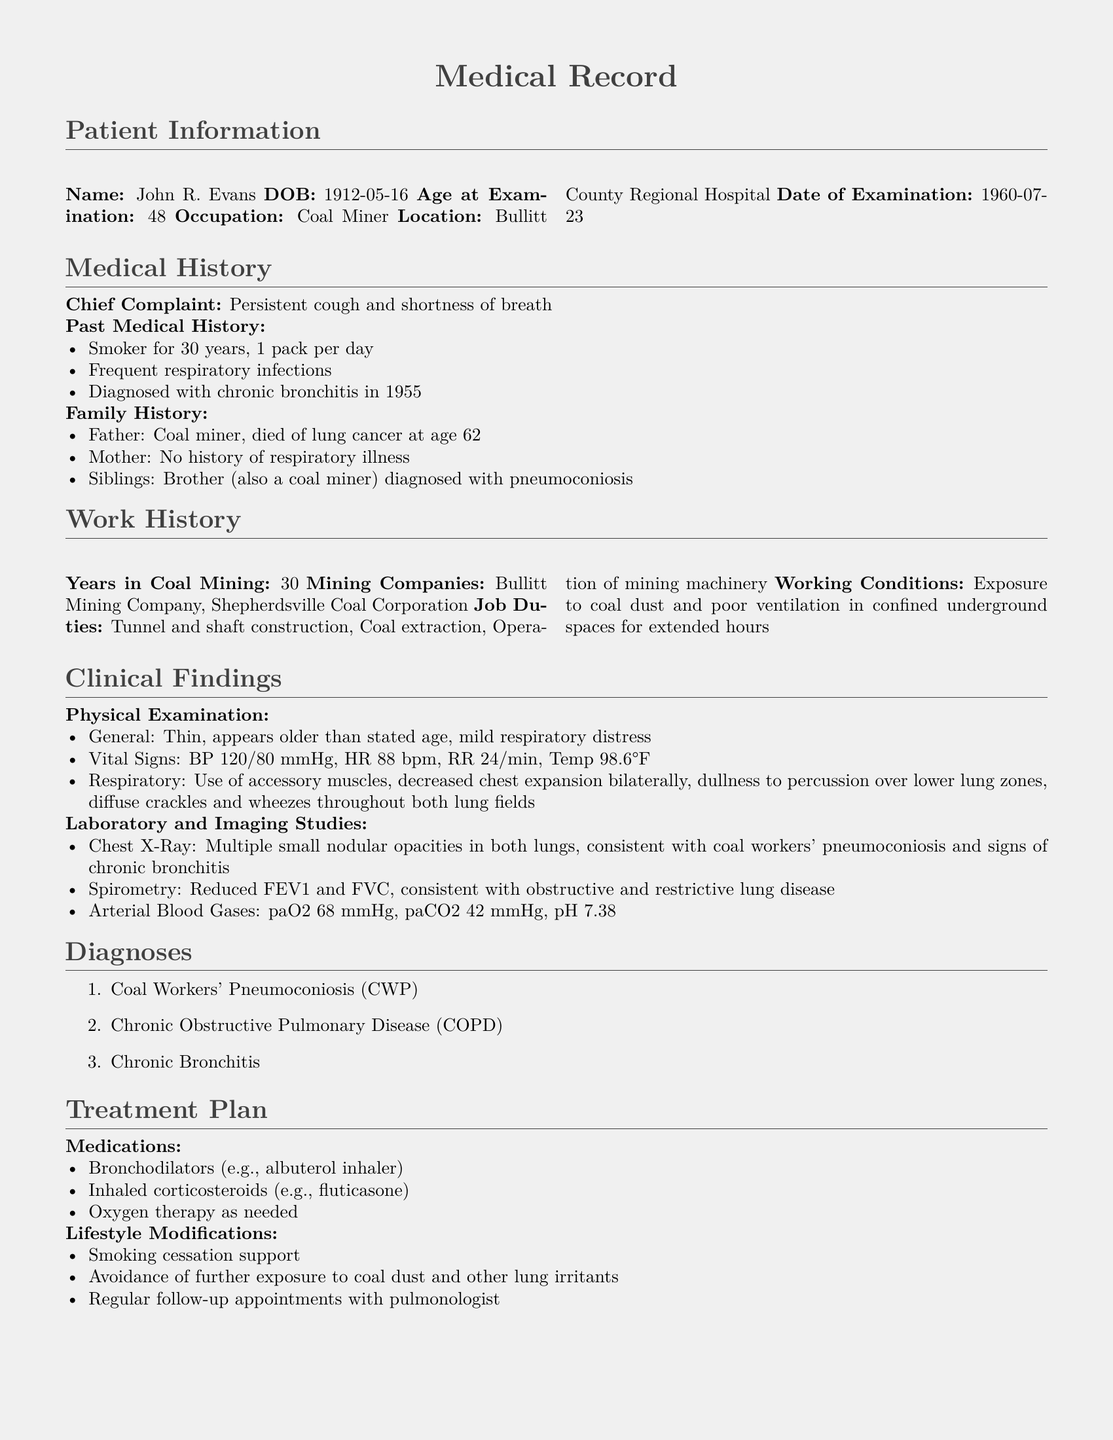What is the name of the patient? The document lists the patient's name.
Answer: John R. Evans What is the date of examination? The date of examination is specified in the patient information section.
Answer: 1960-07-23 What occupation did John R. Evans have? The patient's occupation is mentioned in the document.
Answer: Coal Miner How many years did the patient work in coal mining? This information is provided in the work history section.
Answer: 30 What diagnoses were made? The document provides a list of the diagnoses.
Answer: Coal Workers' Pneumoconiosis, Chronic Obstructive Pulmonary Disease, Chronic Bronchitis What were the vital signs recorded during the physical examination? The document details the vital signs during the examination.
Answer: BP 120/80 mmHg, HR 88 bpm, RR 24/min, Temp 98.6°F What medication is prescribed for smoking cessation support? The treatment plan includes lifestyle modifications for smoking cessation.
Answer: Bronchodilators What kind of respiratory distress was observed? The physical examination describes the type of respiratory distress observed in the patient.
Answer: Mild respiratory distress Who in the patient's family also suffered from a respiratory illness? The family history section discusses relatives with respiratory issues.
Answer: Brother 